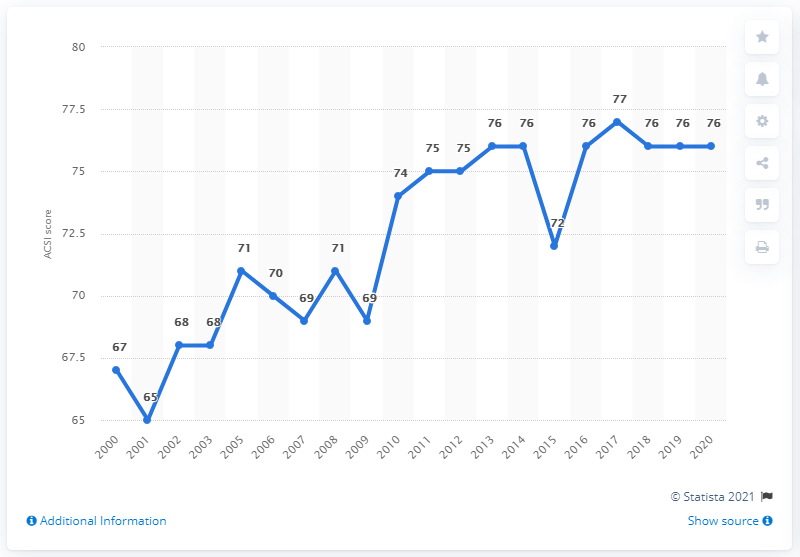Outline some significant characteristics in this image. In 2020, Burger King's ACSI score was 76, indicating a generally positive customer experience. 